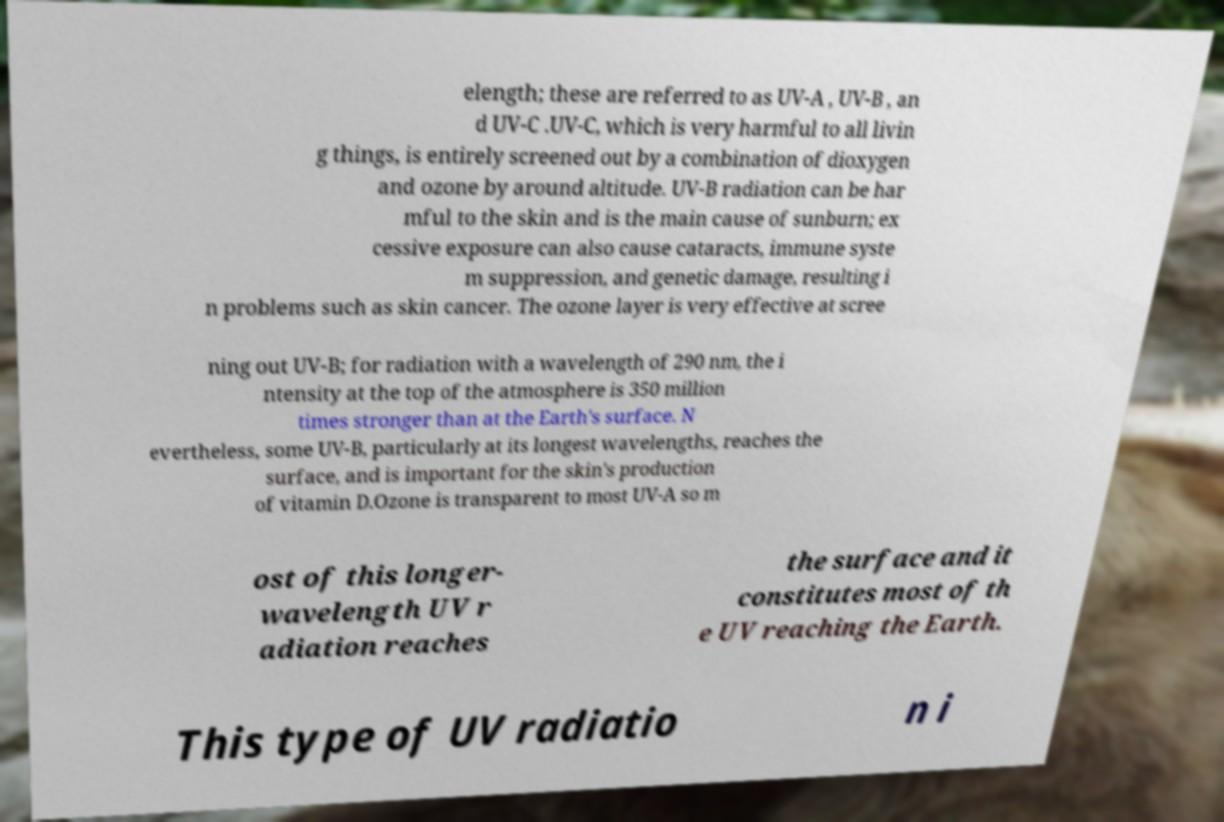Please identify and transcribe the text found in this image. elength; these are referred to as UV-A , UV-B , an d UV-C .UV-C, which is very harmful to all livin g things, is entirely screened out by a combination of dioxygen and ozone by around altitude. UV-B radiation can be har mful to the skin and is the main cause of sunburn; ex cessive exposure can also cause cataracts, immune syste m suppression, and genetic damage, resulting i n problems such as skin cancer. The ozone layer is very effective at scree ning out UV-B; for radiation with a wavelength of 290 nm, the i ntensity at the top of the atmosphere is 350 million times stronger than at the Earth's surface. N evertheless, some UV-B, particularly at its longest wavelengths, reaches the surface, and is important for the skin's production of vitamin D.Ozone is transparent to most UV-A so m ost of this longer- wavelength UV r adiation reaches the surface and it constitutes most of th e UV reaching the Earth. This type of UV radiatio n i 